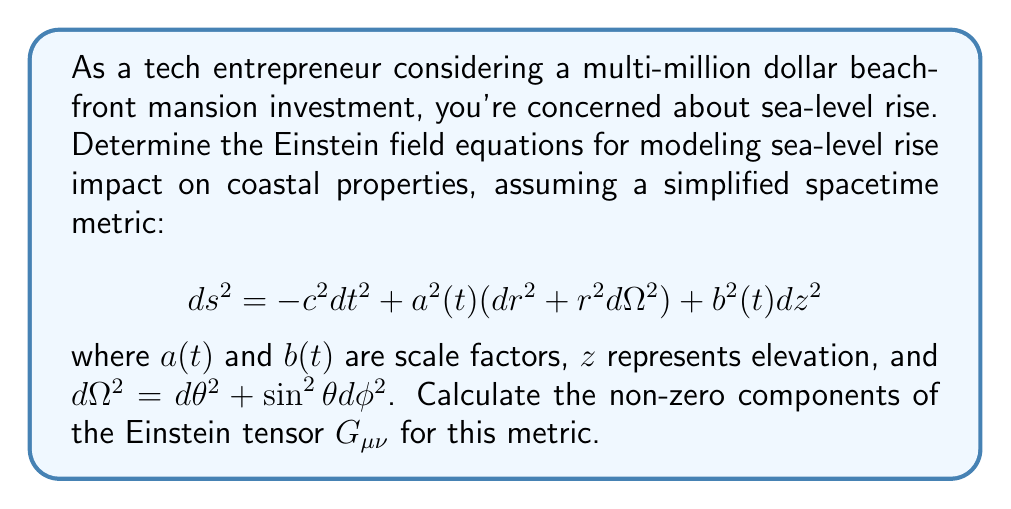Help me with this question. To solve this problem, we'll follow these steps:

1) First, we need to calculate the Christoffel symbols $\Gamma^\mu_{\nu\lambda}$ using the metric components:

   $$\Gamma^\mu_{\nu\lambda} = \frac{1}{2}g^{\mu\sigma}(\partial_\nu g_{\sigma\lambda} + \partial_\lambda g_{\sigma\nu} - \partial_\sigma g_{\nu\lambda})$$

2) Next, we'll use the Christoffel symbols to calculate the Ricci tensor $R_{\mu\nu}$:

   $$R_{\mu\nu} = \partial_\lambda \Gamma^\lambda_{\mu\nu} - \partial_\nu \Gamma^\lambda_{\mu\lambda} + \Gamma^\lambda_{\lambda\sigma}\Gamma^\sigma_{\mu\nu} - \Gamma^\lambda_{\nu\sigma}\Gamma^\sigma_{\mu\lambda}$$

3) We'll then calculate the Ricci scalar $R$:

   $$R = g^{\mu\nu}R_{\mu\nu}$$

4) Finally, we'll use these to compute the Einstein tensor $G_{\mu\nu}$:

   $$G_{\mu\nu} = R_{\mu\nu} - \frac{1}{2}Rg_{\mu\nu}$$

Calculating the non-zero components:

For $G_{00}$:
$$G_{00} = 3(\frac{\dot{a}^2}{a^2} + \frac{\dot{a}\dot{b}}{ab})$$

For $G_{11}$:
$$G_{11} = -a^2(2\frac{\ddot{a}}{a} + \frac{\ddot{b}}{b} + \frac{\dot{a}^2}{a^2} + 2\frac{\dot{a}\dot{b}}{ab})$$

For $G_{22}$:
$$G_{22} = r^2G_{11}$$

For $G_{33}$:
$$G_{33} = -b^2(3\frac{\ddot{a}}{a} + \frac{\dot{a}^2}{a^2})$$

The other components are zero due to the symmetry of the metric.
Answer: $$G_{00} = 3(\frac{\dot{a}^2}{a^2} + \frac{\dot{a}\dot{b}}{ab}), G_{11} = -a^2(2\frac{\ddot{a}}{a} + \frac{\ddot{b}}{b} + \frac{\dot{a}^2}{a^2} + 2\frac{\dot{a}\dot{b}}{ab}), G_{22} = r^2G_{11}, G_{33} = -b^2(3\frac{\ddot{a}}{a} + \frac{\dot{a}^2}{a^2})$$ 